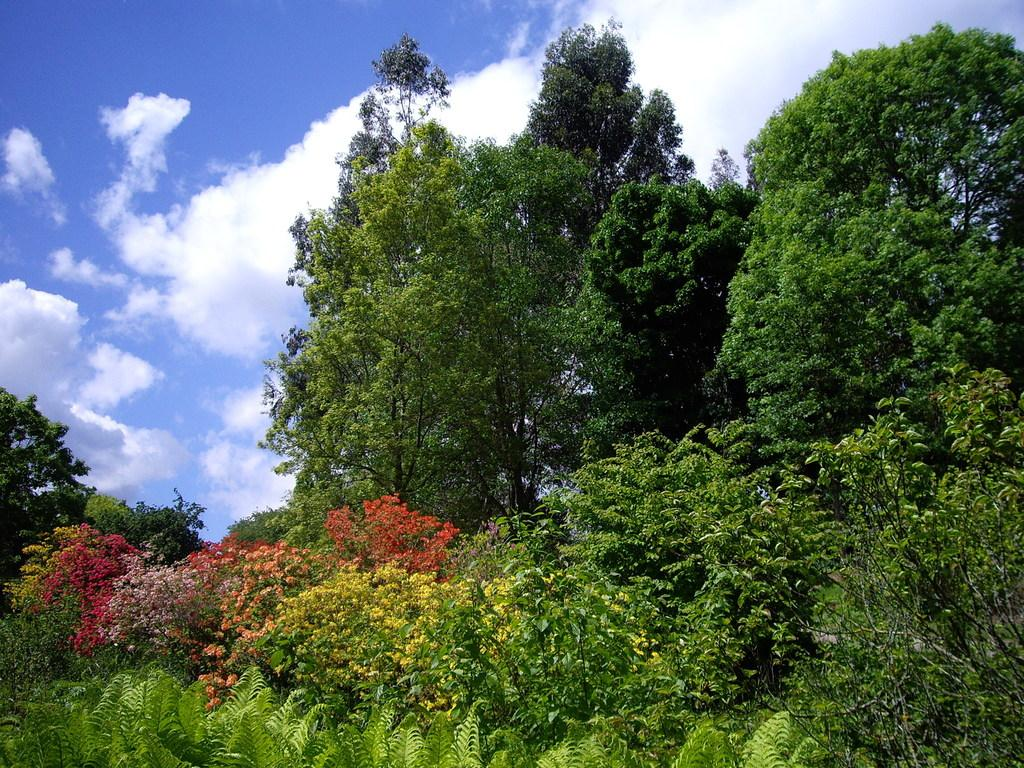What type of vegetation is present in the image? There are many trees, plants, and grass in the image. Where are the flowers located in the image? The flowers are on a plant on the left side of the image. What is visible at the top of the image? The sky is visible at the top of the image. What can be seen in the sky in the image? Clouds are present in the sky. What type of quill is being used to write on the plant in the image? There is no quill or writing activity present in the image. What relation does the plant have with the flowers in the image? The flowers are on a plant in the image, so they are part of the same plant. 